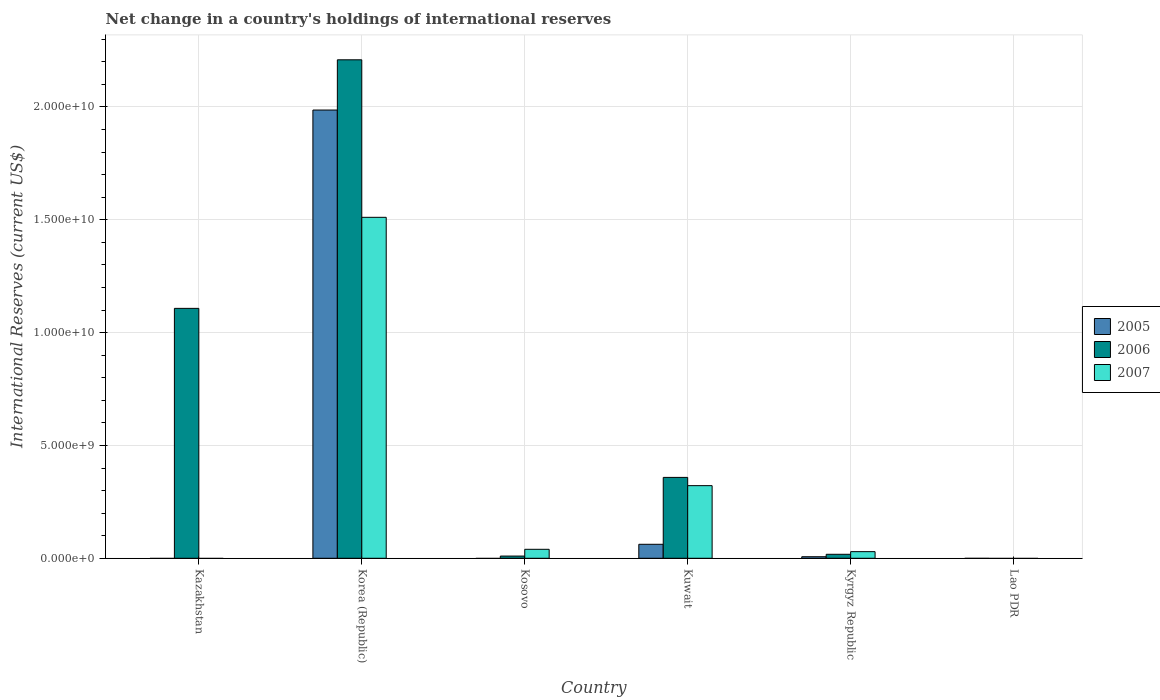How many different coloured bars are there?
Keep it short and to the point. 3. Are the number of bars per tick equal to the number of legend labels?
Keep it short and to the point. No. Are the number of bars on each tick of the X-axis equal?
Keep it short and to the point. No. What is the label of the 4th group of bars from the left?
Make the answer very short. Kuwait. Across all countries, what is the maximum international reserves in 2005?
Keep it short and to the point. 1.99e+1. Across all countries, what is the minimum international reserves in 2005?
Your answer should be compact. 0. In which country was the international reserves in 2007 maximum?
Provide a short and direct response. Korea (Republic). What is the total international reserves in 2006 in the graph?
Ensure brevity in your answer.  3.70e+1. What is the difference between the international reserves in 2005 in Korea (Republic) and that in Kyrgyz Republic?
Offer a very short reply. 1.98e+1. What is the difference between the international reserves in 2006 in Kosovo and the international reserves in 2007 in Korea (Republic)?
Make the answer very short. -1.50e+1. What is the average international reserves in 2005 per country?
Provide a short and direct response. 3.43e+09. What is the difference between the international reserves of/in 2006 and international reserves of/in 2007 in Kuwait?
Offer a terse response. 3.65e+08. What is the ratio of the international reserves in 2007 in Korea (Republic) to that in Kyrgyz Republic?
Your response must be concise. 51.55. What is the difference between the highest and the second highest international reserves in 2005?
Provide a short and direct response. 5.51e+08. What is the difference between the highest and the lowest international reserves in 2007?
Your answer should be very brief. 1.51e+1. In how many countries, is the international reserves in 2006 greater than the average international reserves in 2006 taken over all countries?
Offer a very short reply. 2. How many bars are there?
Make the answer very short. 12. How many countries are there in the graph?
Make the answer very short. 6. What is the difference between two consecutive major ticks on the Y-axis?
Offer a terse response. 5.00e+09. What is the title of the graph?
Make the answer very short. Net change in a country's holdings of international reserves. Does "2003" appear as one of the legend labels in the graph?
Offer a very short reply. No. What is the label or title of the X-axis?
Make the answer very short. Country. What is the label or title of the Y-axis?
Offer a very short reply. International Reserves (current US$). What is the International Reserves (current US$) in 2006 in Kazakhstan?
Keep it short and to the point. 1.11e+1. What is the International Reserves (current US$) of 2005 in Korea (Republic)?
Your answer should be very brief. 1.99e+1. What is the International Reserves (current US$) in 2006 in Korea (Republic)?
Provide a succinct answer. 2.21e+1. What is the International Reserves (current US$) of 2007 in Korea (Republic)?
Your response must be concise. 1.51e+1. What is the International Reserves (current US$) in 2005 in Kosovo?
Keep it short and to the point. 0. What is the International Reserves (current US$) in 2006 in Kosovo?
Your response must be concise. 9.77e+07. What is the International Reserves (current US$) in 2007 in Kosovo?
Provide a short and direct response. 3.97e+08. What is the International Reserves (current US$) in 2005 in Kuwait?
Your answer should be very brief. 6.19e+08. What is the International Reserves (current US$) of 2006 in Kuwait?
Ensure brevity in your answer.  3.58e+09. What is the International Reserves (current US$) in 2007 in Kuwait?
Make the answer very short. 3.22e+09. What is the International Reserves (current US$) in 2005 in Kyrgyz Republic?
Make the answer very short. 6.84e+07. What is the International Reserves (current US$) in 2006 in Kyrgyz Republic?
Keep it short and to the point. 1.77e+08. What is the International Reserves (current US$) in 2007 in Kyrgyz Republic?
Keep it short and to the point. 2.93e+08. Across all countries, what is the maximum International Reserves (current US$) in 2005?
Your answer should be compact. 1.99e+1. Across all countries, what is the maximum International Reserves (current US$) of 2006?
Keep it short and to the point. 2.21e+1. Across all countries, what is the maximum International Reserves (current US$) in 2007?
Provide a succinct answer. 1.51e+1. Across all countries, what is the minimum International Reserves (current US$) in 2005?
Keep it short and to the point. 0. What is the total International Reserves (current US$) of 2005 in the graph?
Your answer should be very brief. 2.06e+1. What is the total International Reserves (current US$) of 2006 in the graph?
Your answer should be very brief. 3.70e+1. What is the total International Reserves (current US$) in 2007 in the graph?
Make the answer very short. 1.90e+1. What is the difference between the International Reserves (current US$) of 2006 in Kazakhstan and that in Korea (Republic)?
Your answer should be compact. -1.10e+1. What is the difference between the International Reserves (current US$) in 2006 in Kazakhstan and that in Kosovo?
Provide a short and direct response. 1.10e+1. What is the difference between the International Reserves (current US$) of 2006 in Kazakhstan and that in Kuwait?
Keep it short and to the point. 7.49e+09. What is the difference between the International Reserves (current US$) in 2006 in Kazakhstan and that in Kyrgyz Republic?
Your answer should be very brief. 1.09e+1. What is the difference between the International Reserves (current US$) of 2006 in Korea (Republic) and that in Kosovo?
Your answer should be very brief. 2.20e+1. What is the difference between the International Reserves (current US$) in 2007 in Korea (Republic) and that in Kosovo?
Provide a short and direct response. 1.47e+1. What is the difference between the International Reserves (current US$) of 2005 in Korea (Republic) and that in Kuwait?
Your answer should be compact. 1.92e+1. What is the difference between the International Reserves (current US$) in 2006 in Korea (Republic) and that in Kuwait?
Offer a very short reply. 1.85e+1. What is the difference between the International Reserves (current US$) of 2007 in Korea (Republic) and that in Kuwait?
Your answer should be very brief. 1.19e+1. What is the difference between the International Reserves (current US$) of 2005 in Korea (Republic) and that in Kyrgyz Republic?
Your response must be concise. 1.98e+1. What is the difference between the International Reserves (current US$) in 2006 in Korea (Republic) and that in Kyrgyz Republic?
Make the answer very short. 2.19e+1. What is the difference between the International Reserves (current US$) of 2007 in Korea (Republic) and that in Kyrgyz Republic?
Make the answer very short. 1.48e+1. What is the difference between the International Reserves (current US$) in 2006 in Kosovo and that in Kuwait?
Provide a succinct answer. -3.49e+09. What is the difference between the International Reserves (current US$) of 2007 in Kosovo and that in Kuwait?
Keep it short and to the point. -2.82e+09. What is the difference between the International Reserves (current US$) of 2006 in Kosovo and that in Kyrgyz Republic?
Provide a short and direct response. -7.90e+07. What is the difference between the International Reserves (current US$) of 2007 in Kosovo and that in Kyrgyz Republic?
Provide a short and direct response. 1.04e+08. What is the difference between the International Reserves (current US$) in 2005 in Kuwait and that in Kyrgyz Republic?
Provide a succinct answer. 5.51e+08. What is the difference between the International Reserves (current US$) of 2006 in Kuwait and that in Kyrgyz Republic?
Provide a succinct answer. 3.41e+09. What is the difference between the International Reserves (current US$) in 2007 in Kuwait and that in Kyrgyz Republic?
Keep it short and to the point. 2.93e+09. What is the difference between the International Reserves (current US$) of 2006 in Kazakhstan and the International Reserves (current US$) of 2007 in Korea (Republic)?
Offer a very short reply. -4.03e+09. What is the difference between the International Reserves (current US$) in 2006 in Kazakhstan and the International Reserves (current US$) in 2007 in Kosovo?
Provide a short and direct response. 1.07e+1. What is the difference between the International Reserves (current US$) of 2006 in Kazakhstan and the International Reserves (current US$) of 2007 in Kuwait?
Offer a very short reply. 7.86e+09. What is the difference between the International Reserves (current US$) of 2006 in Kazakhstan and the International Reserves (current US$) of 2007 in Kyrgyz Republic?
Your answer should be compact. 1.08e+1. What is the difference between the International Reserves (current US$) in 2005 in Korea (Republic) and the International Reserves (current US$) in 2006 in Kosovo?
Ensure brevity in your answer.  1.98e+1. What is the difference between the International Reserves (current US$) of 2005 in Korea (Republic) and the International Reserves (current US$) of 2007 in Kosovo?
Ensure brevity in your answer.  1.95e+1. What is the difference between the International Reserves (current US$) in 2006 in Korea (Republic) and the International Reserves (current US$) in 2007 in Kosovo?
Your answer should be compact. 2.17e+1. What is the difference between the International Reserves (current US$) in 2005 in Korea (Republic) and the International Reserves (current US$) in 2006 in Kuwait?
Give a very brief answer. 1.63e+1. What is the difference between the International Reserves (current US$) of 2005 in Korea (Republic) and the International Reserves (current US$) of 2007 in Kuwait?
Give a very brief answer. 1.66e+1. What is the difference between the International Reserves (current US$) of 2006 in Korea (Republic) and the International Reserves (current US$) of 2007 in Kuwait?
Provide a short and direct response. 1.89e+1. What is the difference between the International Reserves (current US$) of 2005 in Korea (Republic) and the International Reserves (current US$) of 2006 in Kyrgyz Republic?
Ensure brevity in your answer.  1.97e+1. What is the difference between the International Reserves (current US$) of 2005 in Korea (Republic) and the International Reserves (current US$) of 2007 in Kyrgyz Republic?
Give a very brief answer. 1.96e+1. What is the difference between the International Reserves (current US$) in 2006 in Korea (Republic) and the International Reserves (current US$) in 2007 in Kyrgyz Republic?
Your response must be concise. 2.18e+1. What is the difference between the International Reserves (current US$) in 2006 in Kosovo and the International Reserves (current US$) in 2007 in Kuwait?
Your response must be concise. -3.12e+09. What is the difference between the International Reserves (current US$) of 2006 in Kosovo and the International Reserves (current US$) of 2007 in Kyrgyz Republic?
Offer a very short reply. -1.95e+08. What is the difference between the International Reserves (current US$) of 2005 in Kuwait and the International Reserves (current US$) of 2006 in Kyrgyz Republic?
Give a very brief answer. 4.43e+08. What is the difference between the International Reserves (current US$) of 2005 in Kuwait and the International Reserves (current US$) of 2007 in Kyrgyz Republic?
Ensure brevity in your answer.  3.26e+08. What is the difference between the International Reserves (current US$) of 2006 in Kuwait and the International Reserves (current US$) of 2007 in Kyrgyz Republic?
Your response must be concise. 3.29e+09. What is the average International Reserves (current US$) in 2005 per country?
Your answer should be compact. 3.43e+09. What is the average International Reserves (current US$) in 2006 per country?
Offer a terse response. 6.17e+09. What is the average International Reserves (current US$) of 2007 per country?
Keep it short and to the point. 3.17e+09. What is the difference between the International Reserves (current US$) in 2005 and International Reserves (current US$) in 2006 in Korea (Republic)?
Give a very brief answer. -2.23e+09. What is the difference between the International Reserves (current US$) of 2005 and International Reserves (current US$) of 2007 in Korea (Republic)?
Make the answer very short. 4.75e+09. What is the difference between the International Reserves (current US$) in 2006 and International Reserves (current US$) in 2007 in Korea (Republic)?
Offer a very short reply. 6.98e+09. What is the difference between the International Reserves (current US$) in 2006 and International Reserves (current US$) in 2007 in Kosovo?
Your answer should be very brief. -3.00e+08. What is the difference between the International Reserves (current US$) of 2005 and International Reserves (current US$) of 2006 in Kuwait?
Your answer should be very brief. -2.96e+09. What is the difference between the International Reserves (current US$) of 2005 and International Reserves (current US$) of 2007 in Kuwait?
Your answer should be very brief. -2.60e+09. What is the difference between the International Reserves (current US$) of 2006 and International Reserves (current US$) of 2007 in Kuwait?
Offer a very short reply. 3.65e+08. What is the difference between the International Reserves (current US$) of 2005 and International Reserves (current US$) of 2006 in Kyrgyz Republic?
Provide a short and direct response. -1.08e+08. What is the difference between the International Reserves (current US$) in 2005 and International Reserves (current US$) in 2007 in Kyrgyz Republic?
Keep it short and to the point. -2.25e+08. What is the difference between the International Reserves (current US$) of 2006 and International Reserves (current US$) of 2007 in Kyrgyz Republic?
Offer a terse response. -1.16e+08. What is the ratio of the International Reserves (current US$) in 2006 in Kazakhstan to that in Korea (Republic)?
Give a very brief answer. 0.5. What is the ratio of the International Reserves (current US$) in 2006 in Kazakhstan to that in Kosovo?
Provide a succinct answer. 113.36. What is the ratio of the International Reserves (current US$) in 2006 in Kazakhstan to that in Kuwait?
Ensure brevity in your answer.  3.09. What is the ratio of the International Reserves (current US$) of 2006 in Kazakhstan to that in Kyrgyz Republic?
Offer a very short reply. 62.67. What is the ratio of the International Reserves (current US$) in 2006 in Korea (Republic) to that in Kosovo?
Provide a succinct answer. 226.12. What is the ratio of the International Reserves (current US$) of 2007 in Korea (Republic) to that in Kosovo?
Provide a succinct answer. 38.03. What is the ratio of the International Reserves (current US$) in 2005 in Korea (Republic) to that in Kuwait?
Offer a terse response. 32.07. What is the ratio of the International Reserves (current US$) in 2006 in Korea (Republic) to that in Kuwait?
Provide a short and direct response. 6.16. What is the ratio of the International Reserves (current US$) of 2007 in Korea (Republic) to that in Kuwait?
Provide a short and direct response. 4.69. What is the ratio of the International Reserves (current US$) in 2005 in Korea (Republic) to that in Kyrgyz Republic?
Provide a succinct answer. 290.49. What is the ratio of the International Reserves (current US$) of 2006 in Korea (Republic) to that in Kyrgyz Republic?
Your answer should be compact. 125. What is the ratio of the International Reserves (current US$) in 2007 in Korea (Republic) to that in Kyrgyz Republic?
Your response must be concise. 51.55. What is the ratio of the International Reserves (current US$) in 2006 in Kosovo to that in Kuwait?
Your answer should be compact. 0.03. What is the ratio of the International Reserves (current US$) of 2007 in Kosovo to that in Kuwait?
Your answer should be compact. 0.12. What is the ratio of the International Reserves (current US$) in 2006 in Kosovo to that in Kyrgyz Republic?
Provide a short and direct response. 0.55. What is the ratio of the International Reserves (current US$) of 2007 in Kosovo to that in Kyrgyz Republic?
Keep it short and to the point. 1.36. What is the ratio of the International Reserves (current US$) of 2005 in Kuwait to that in Kyrgyz Republic?
Your answer should be compact. 9.06. What is the ratio of the International Reserves (current US$) in 2006 in Kuwait to that in Kyrgyz Republic?
Keep it short and to the point. 20.28. What is the ratio of the International Reserves (current US$) of 2007 in Kuwait to that in Kyrgyz Republic?
Offer a terse response. 10.98. What is the difference between the highest and the second highest International Reserves (current US$) of 2005?
Your answer should be compact. 1.92e+1. What is the difference between the highest and the second highest International Reserves (current US$) in 2006?
Offer a terse response. 1.10e+1. What is the difference between the highest and the second highest International Reserves (current US$) of 2007?
Ensure brevity in your answer.  1.19e+1. What is the difference between the highest and the lowest International Reserves (current US$) of 2005?
Your answer should be very brief. 1.99e+1. What is the difference between the highest and the lowest International Reserves (current US$) in 2006?
Provide a short and direct response. 2.21e+1. What is the difference between the highest and the lowest International Reserves (current US$) in 2007?
Make the answer very short. 1.51e+1. 